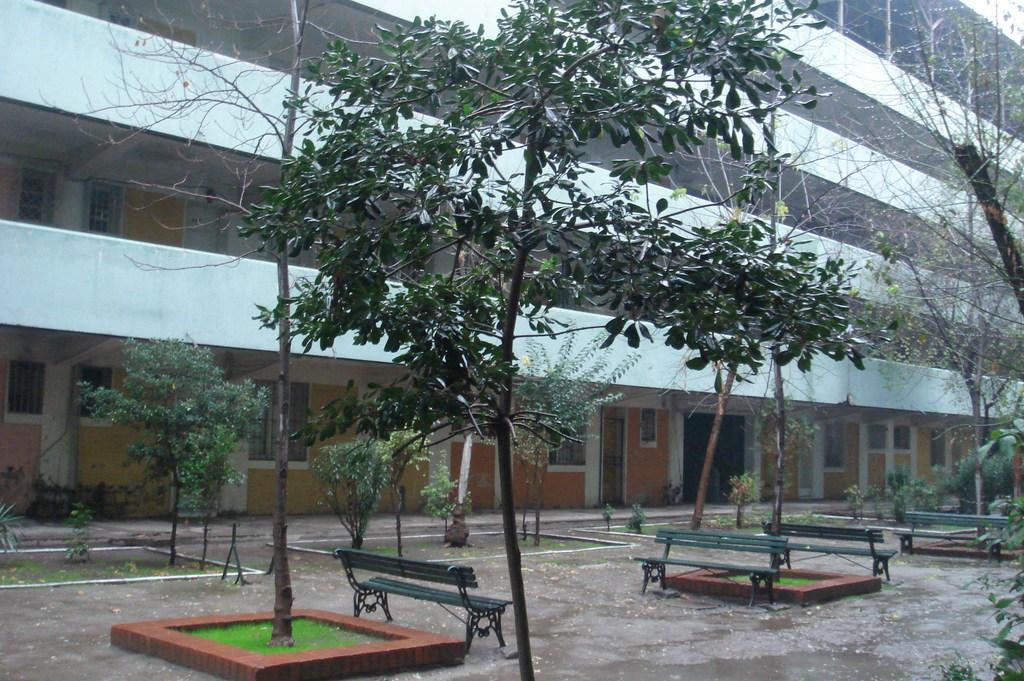What type of vegetation can be seen in the image? There are trees and plants in the image. What type of seating is available in the image? There are benches in the image. What can be seen in the background of the image? There is a building in the background of the image. What type of development is taking place in the image? There is no indication of any development taking place in the image; it primarily features trees, plants, benches, and a building in the background. 